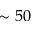Convert formula to latex. <formula><loc_0><loc_0><loc_500><loc_500>\sim 5 0</formula> 